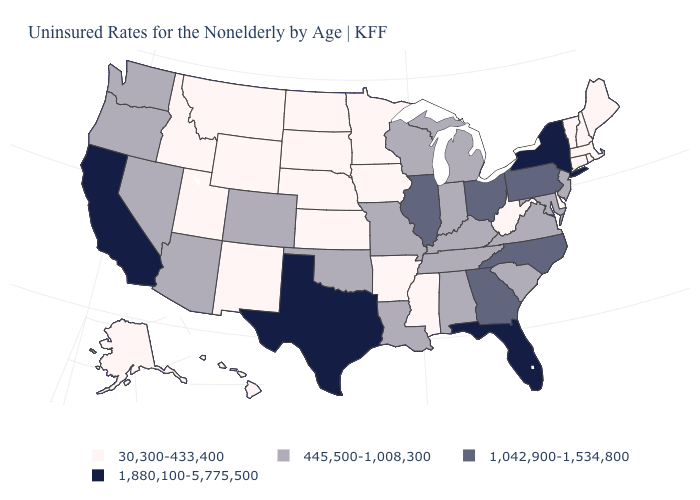What is the lowest value in states that border Virginia?
Answer briefly. 30,300-433,400. How many symbols are there in the legend?
Be succinct. 4. Name the states that have a value in the range 30,300-433,400?
Short answer required. Alaska, Arkansas, Connecticut, Delaware, Hawaii, Idaho, Iowa, Kansas, Maine, Massachusetts, Minnesota, Mississippi, Montana, Nebraska, New Hampshire, New Mexico, North Dakota, Rhode Island, South Dakota, Utah, Vermont, West Virginia, Wyoming. Does Missouri have the highest value in the MidWest?
Give a very brief answer. No. Name the states that have a value in the range 1,880,100-5,775,500?
Be succinct. California, Florida, New York, Texas. Does Indiana have the same value as Georgia?
Be succinct. No. Name the states that have a value in the range 30,300-433,400?
Be succinct. Alaska, Arkansas, Connecticut, Delaware, Hawaii, Idaho, Iowa, Kansas, Maine, Massachusetts, Minnesota, Mississippi, Montana, Nebraska, New Hampshire, New Mexico, North Dakota, Rhode Island, South Dakota, Utah, Vermont, West Virginia, Wyoming. Name the states that have a value in the range 1,880,100-5,775,500?
Write a very short answer. California, Florida, New York, Texas. What is the highest value in the USA?
Short answer required. 1,880,100-5,775,500. Name the states that have a value in the range 445,500-1,008,300?
Short answer required. Alabama, Arizona, Colorado, Indiana, Kentucky, Louisiana, Maryland, Michigan, Missouri, Nevada, New Jersey, Oklahoma, Oregon, South Carolina, Tennessee, Virginia, Washington, Wisconsin. Does Oklahoma have the lowest value in the South?
Concise answer only. No. Name the states that have a value in the range 1,042,900-1,534,800?
Give a very brief answer. Georgia, Illinois, North Carolina, Ohio, Pennsylvania. What is the value of Kentucky?
Quick response, please. 445,500-1,008,300. Name the states that have a value in the range 1,042,900-1,534,800?
Give a very brief answer. Georgia, Illinois, North Carolina, Ohio, Pennsylvania. Does the map have missing data?
Quick response, please. No. 